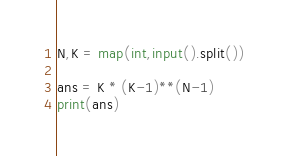<code> <loc_0><loc_0><loc_500><loc_500><_Python_>N,K = map(int,input().split())

ans = K * (K-1)**(N-1)
print(ans)</code> 